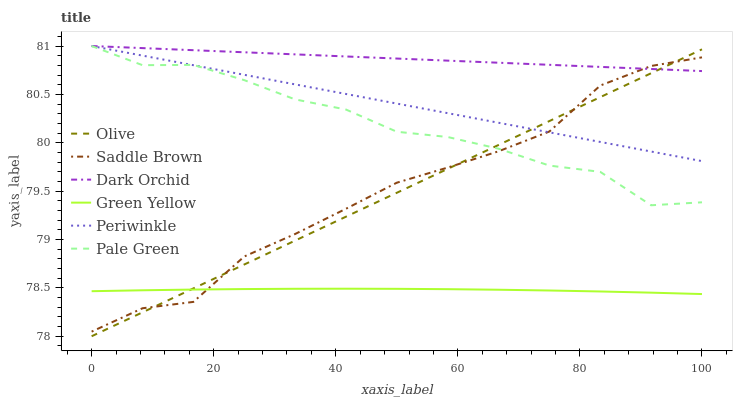Does Pale Green have the minimum area under the curve?
Answer yes or no. No. Does Pale Green have the maximum area under the curve?
Answer yes or no. No. Is Periwinkle the smoothest?
Answer yes or no. No. Is Periwinkle the roughest?
Answer yes or no. No. Does Pale Green have the lowest value?
Answer yes or no. No. Does Olive have the highest value?
Answer yes or no. No. Is Green Yellow less than Pale Green?
Answer yes or no. Yes. Is Pale Green greater than Green Yellow?
Answer yes or no. Yes. Does Green Yellow intersect Pale Green?
Answer yes or no. No. 